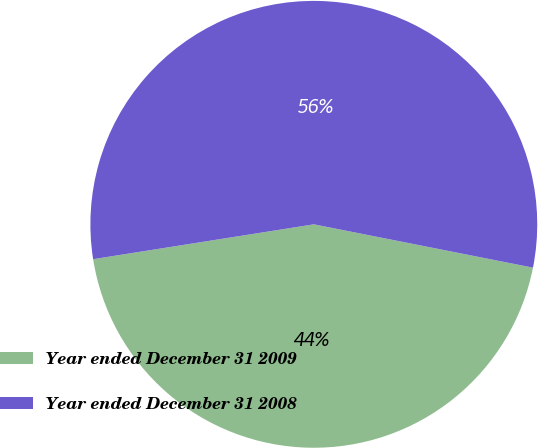<chart> <loc_0><loc_0><loc_500><loc_500><pie_chart><fcel>Year ended December 31 2009<fcel>Year ended December 31 2008<nl><fcel>44.4%<fcel>55.6%<nl></chart> 